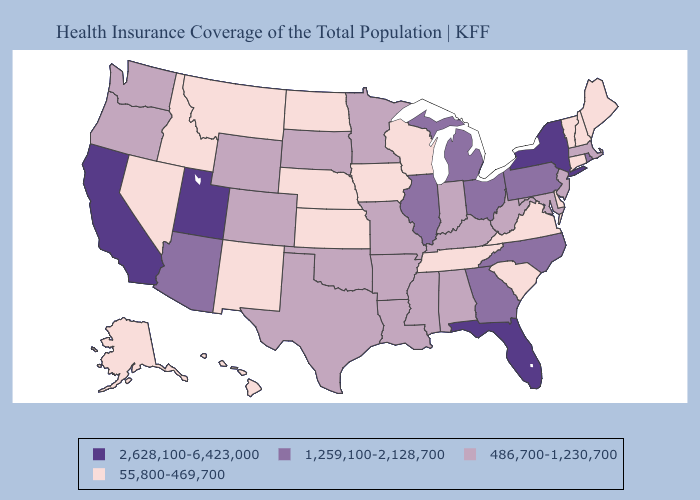Does Wisconsin have the highest value in the USA?
Concise answer only. No. Among the states that border Alabama , does Georgia have the highest value?
Give a very brief answer. No. What is the highest value in the USA?
Keep it brief. 2,628,100-6,423,000. Does Kentucky have the same value as Kansas?
Answer briefly. No. Which states hav the highest value in the South?
Write a very short answer. Florida. How many symbols are there in the legend?
Concise answer only. 4. What is the highest value in states that border Nebraska?
Quick response, please. 486,700-1,230,700. Does Kentucky have the highest value in the USA?
Give a very brief answer. No. Name the states that have a value in the range 2,628,100-6,423,000?
Write a very short answer. California, Florida, New York, Utah. Name the states that have a value in the range 55,800-469,700?
Write a very short answer. Alaska, Connecticut, Delaware, Hawaii, Idaho, Iowa, Kansas, Maine, Montana, Nebraska, Nevada, New Hampshire, New Mexico, North Dakota, South Carolina, Tennessee, Vermont, Virginia, Wisconsin. Among the states that border West Virginia , does Virginia have the lowest value?
Answer briefly. Yes. Does Georgia have the same value as Ohio?
Be succinct. Yes. Which states hav the highest value in the MidWest?
Concise answer only. Illinois, Michigan, Ohio. What is the value of Rhode Island?
Quick response, please. 1,259,100-2,128,700. Does Utah have the highest value in the USA?
Keep it brief. Yes. 